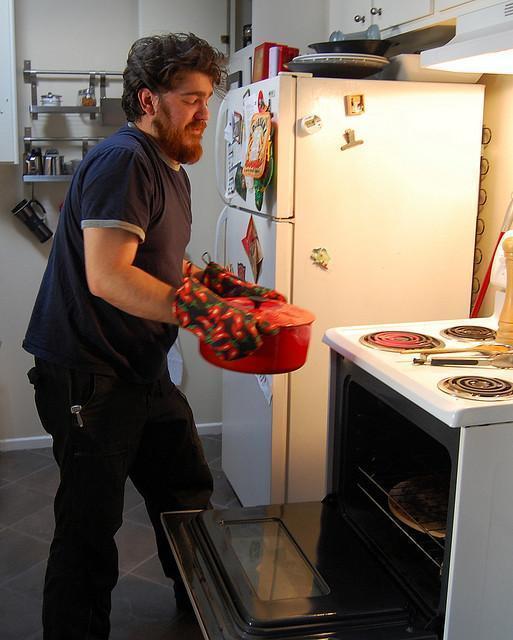What allows him to see the contents of the oven when the door is closed?
Make your selection from the four choices given to correctly answer the question.
Options: Camera, magnifying glass, window, streaming video. Window. 